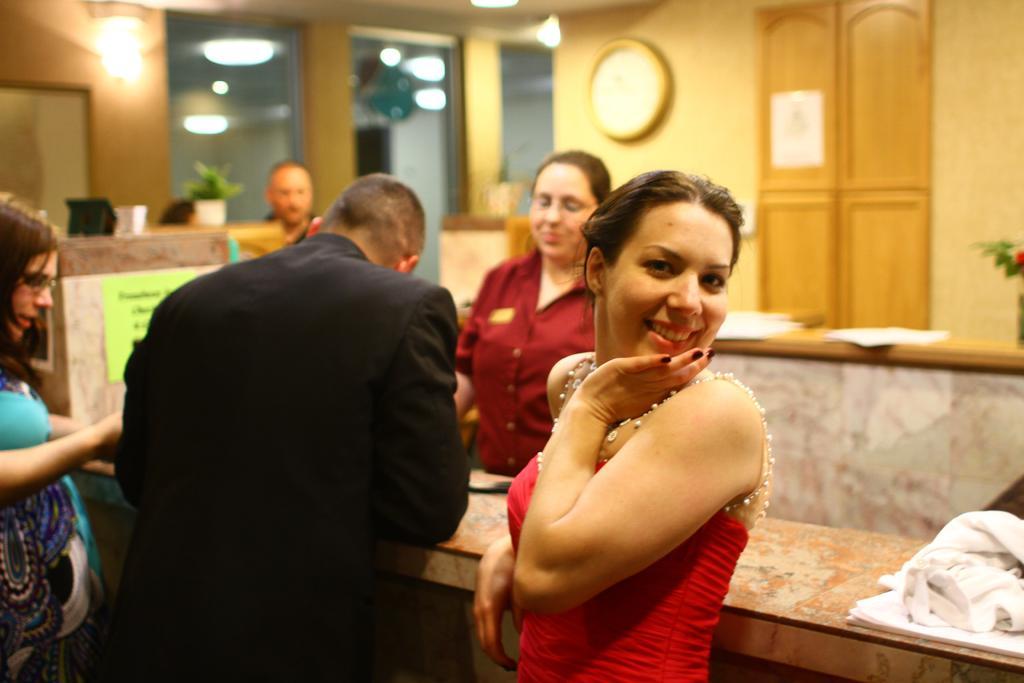Describe this image in one or two sentences. In this image I can see few persons visible in front of table, on the right side there are some leaves, wall, clock attached to the wall, papers kept on table, books, cloth kept on table visible, on the left side there is a flower pot might be kept on table, at the top there are some lights, glass window visible. 